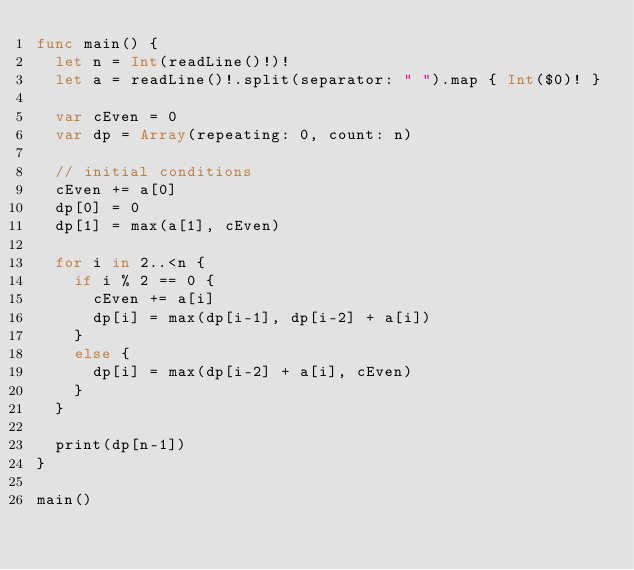Convert code to text. <code><loc_0><loc_0><loc_500><loc_500><_Swift_>func main() {
  let n = Int(readLine()!)!
  let a = readLine()!.split(separator: " ").map { Int($0)! }

  var cEven = 0
  var dp = Array(repeating: 0, count: n)
  
  // initial conditions
  cEven += a[0]
  dp[0] = 0
  dp[1] = max(a[1], cEven)

  for i in 2..<n {
    if i % 2 == 0 {
      cEven += a[i]
      dp[i] = max(dp[i-1], dp[i-2] + a[i])
    }
    else {
      dp[i] = max(dp[i-2] + a[i], cEven)
    }
  }

  print(dp[n-1])
}

main()
</code> 